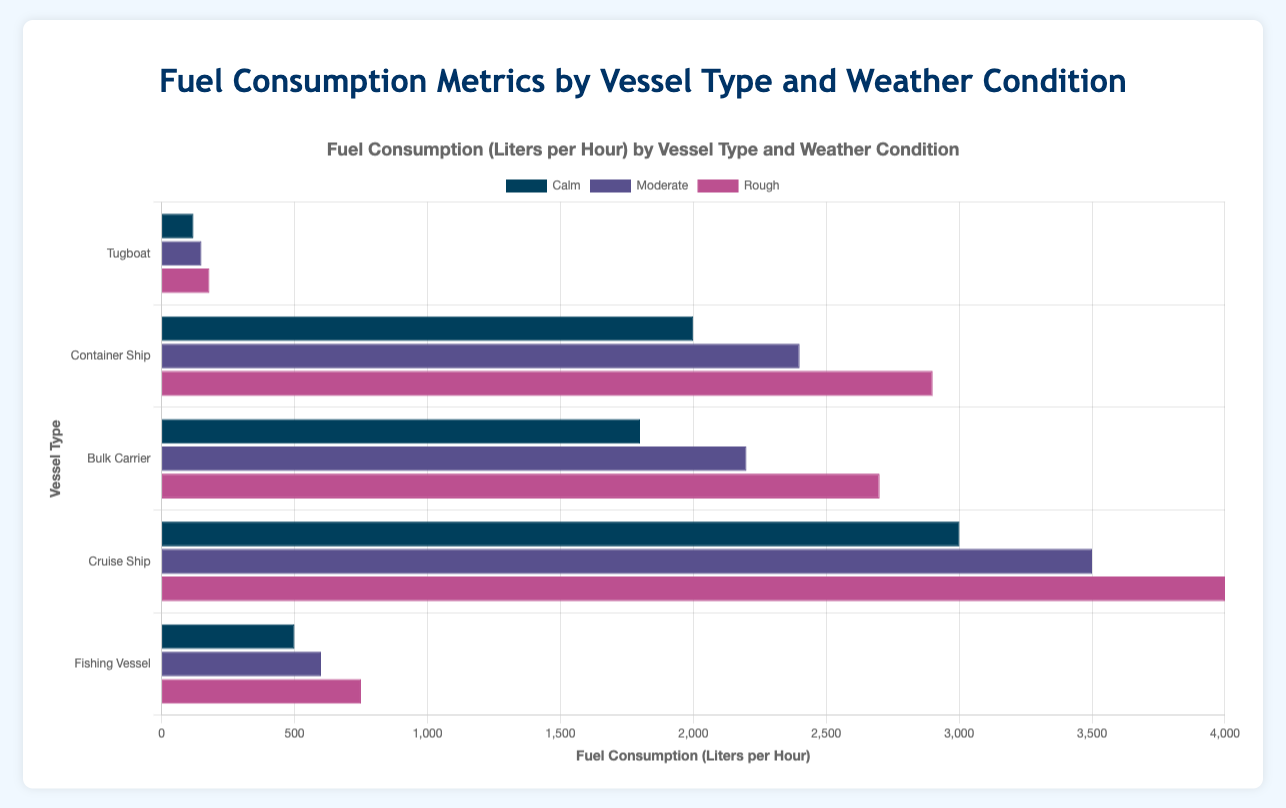Which vessel type has the highest fuel consumption under rough weather conditions? To find the highest fuel consumption under rough weather conditions, compare the values for each vessel type. Tugboat has 180 lph, Container Ship has 2900 lph, Bulk Carrier has 2700 lph, Cruise Ship has 4000 lph, and Fishing Vessel has 750 lph. The Cruise Ship has the highest fuel consumption at 4000 lph.
Answer: Cruise Ship Which weather condition results in the highest fuel consumption for Container Ships? For Container Ships, look at the fuel consumption under each weather condition: Calm (2000 lph), Moderate (2400 lph), and Rough (2900 lph). The highest fuel consumption occurs under Rough weather conditions at 2900 lph.
Answer: Rough By how much does the fuel consumption of a Cruise Ship increase from Calm to Rough weather conditions? Subtract the fuel consumption for Calm weather (3000 lph) from the fuel consumption for Rough weather (4000 lph). 4000 - 3000 = 1000 lph.
Answer: 1000 lph Which vessel type shows the smallest increase in fuel consumption from Moderate to Rough weather conditions? Calculate the increase for each vessel type from Moderate to Rough: Tugboat (180 - 150 = 30), Container Ship (2900 - 2400 = 500), Bulk Carrier (2700 - 2200 = 500), Cruise Ship (4000 - 3500 = 500), Fishing Vessel (750 - 600 = 150). Tugboat has the smallest increase of 30 lph.
Answer: Tugboat What is the total fuel consumption for all vessel types under Calm weather conditions? Sum the fuel consumption for all vessel types under Calm weather: Tugboat (120), Container Ship (2000), Bulk Carrier (1800), Cruise Ship (3000), Fishing Vessel (500). 120 + 2000 + 1800 + 3000 + 500 = 7420 lph.
Answer: 7420 lph For which vessel type is the difference in fuel consumption between Calm and Moderate weather conditions the largest? Calculate the difference for each vessel type between Calm and Moderate: Tugboat (150 - 120 = 30), Container Ship (2400 - 2000 = 400), Bulk Carrier (2200 - 1800 = 400), Cruise Ship (3500 - 3000 = 500), Fishing Vessel (600 - 500 = 100). The Cruise Ship has the largest difference at 500 lph.
Answer: Cruise Ship What is the average fuel consumption for Fishing Vessels across all weather conditions? Sum the fuel consumptions for all weather conditions and divide by the number of conditions: (500 + 600 + 750) / 3 = 1850 / 3 ≈ 617 lph.
Answer: 617 lph What color represents the Rough weather condition in the bar chart? By examining the visual attributes, the Rough weather condition is represented by the color pink in the bar chart.
Answer: pink How does the fuel consumption of a Bulk Carrier in Moderate weather compare with a Fishing Vessel in Rough weather? Compare the fuel consumption values: Bulk Carrier in Moderate weather has 2200 lph, and Fishing Vessel in Rough weather has 750 lph. The Bulk Carrier consumes more fuel.
Answer: Bulk Carrier What is the fuel consumption difference between a Tugboat and a Container Ship in Calm weather? Subtract the fuel consumption of the Tugboat from that of the Container Ship in Calm weather: 2000 - 120 = 1880 lph.
Answer: 1880 lph 